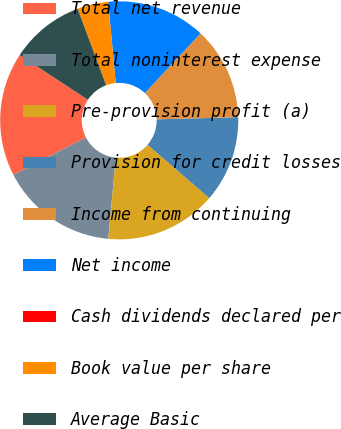Convert chart. <chart><loc_0><loc_0><loc_500><loc_500><pie_chart><fcel>Total net revenue<fcel>Total noninterest expense<fcel>Pre-provision profit (a)<fcel>Provision for credit losses<fcel>Income from continuing<fcel>Net income<fcel>Cash dividends declared per<fcel>Book value per share<fcel>Average Basic<nl><fcel>16.81%<fcel>15.97%<fcel>15.13%<fcel>11.76%<fcel>12.61%<fcel>13.45%<fcel>0.0%<fcel>4.2%<fcel>10.08%<nl></chart> 